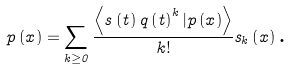Convert formula to latex. <formula><loc_0><loc_0><loc_500><loc_500>p \left ( x \right ) = \sum _ { k \geq 0 } \frac { \left \langle s \left ( t \right ) q \left ( t \right ) ^ { k } | p \left ( x \right ) \right \rangle } { k ! } s _ { k } \left ( x \right ) \text {.}</formula> 